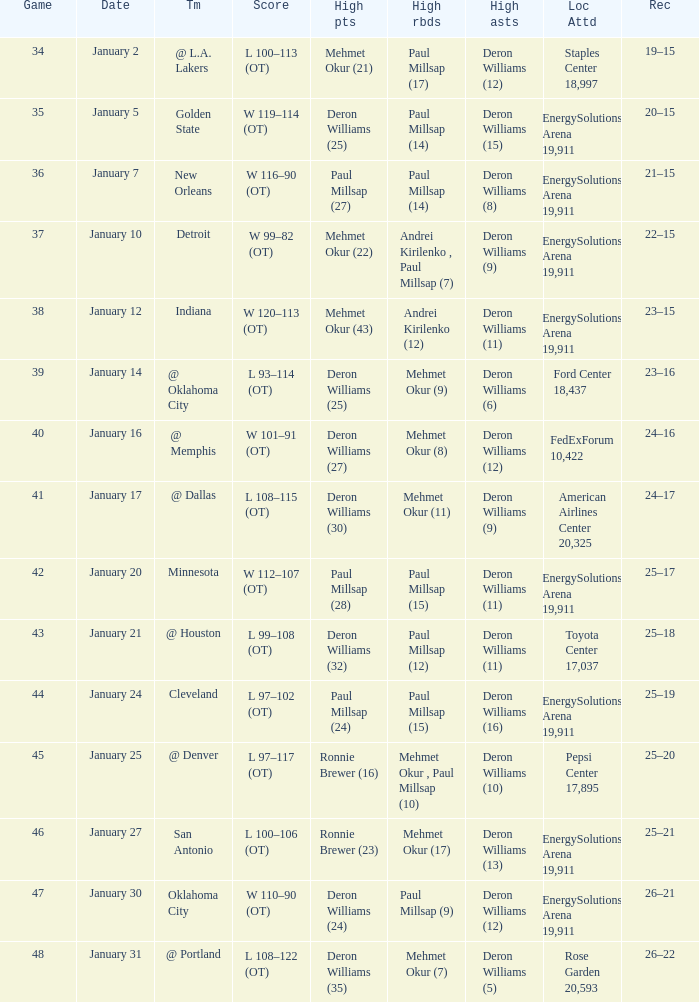Who had the high rebounds of the game that Deron Williams (5) had the high assists? Mehmet Okur (7). 